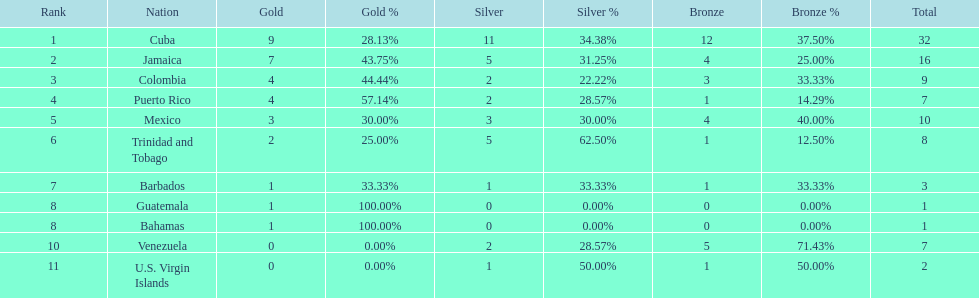Nations that had 10 or more medals each Cuba, Jamaica, Mexico. 